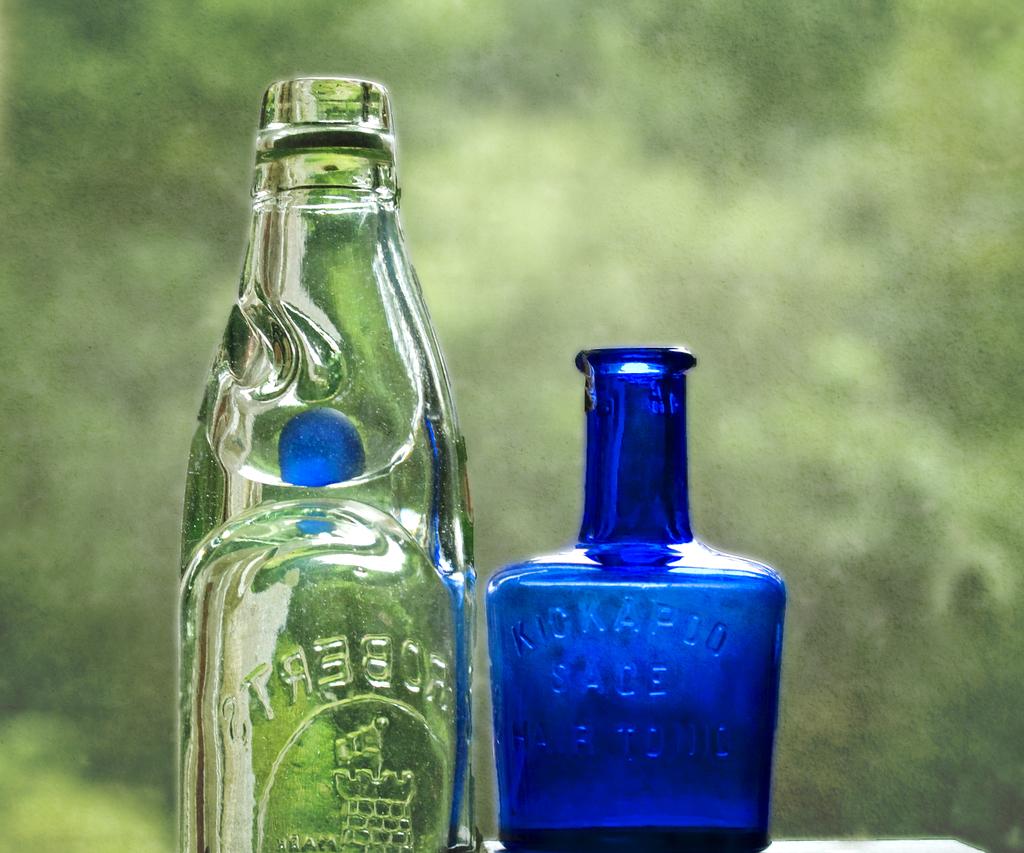What kind of tonic was in the blue bottle?
Provide a short and direct response. Hair. 